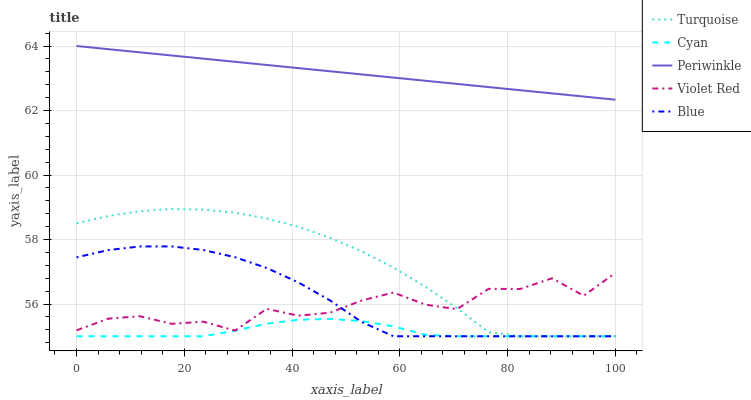Does Cyan have the minimum area under the curve?
Answer yes or no. Yes. Does Periwinkle have the maximum area under the curve?
Answer yes or no. Yes. Does Turquoise have the minimum area under the curve?
Answer yes or no. No. Does Turquoise have the maximum area under the curve?
Answer yes or no. No. Is Periwinkle the smoothest?
Answer yes or no. Yes. Is Violet Red the roughest?
Answer yes or no. Yes. Is Cyan the smoothest?
Answer yes or no. No. Is Cyan the roughest?
Answer yes or no. No. Does Periwinkle have the lowest value?
Answer yes or no. No. Does Periwinkle have the highest value?
Answer yes or no. Yes. Does Turquoise have the highest value?
Answer yes or no. No. Is Cyan less than Violet Red?
Answer yes or no. Yes. Is Periwinkle greater than Violet Red?
Answer yes or no. Yes. Does Cyan intersect Turquoise?
Answer yes or no. Yes. Is Cyan less than Turquoise?
Answer yes or no. No. Is Cyan greater than Turquoise?
Answer yes or no. No. Does Cyan intersect Violet Red?
Answer yes or no. No. 